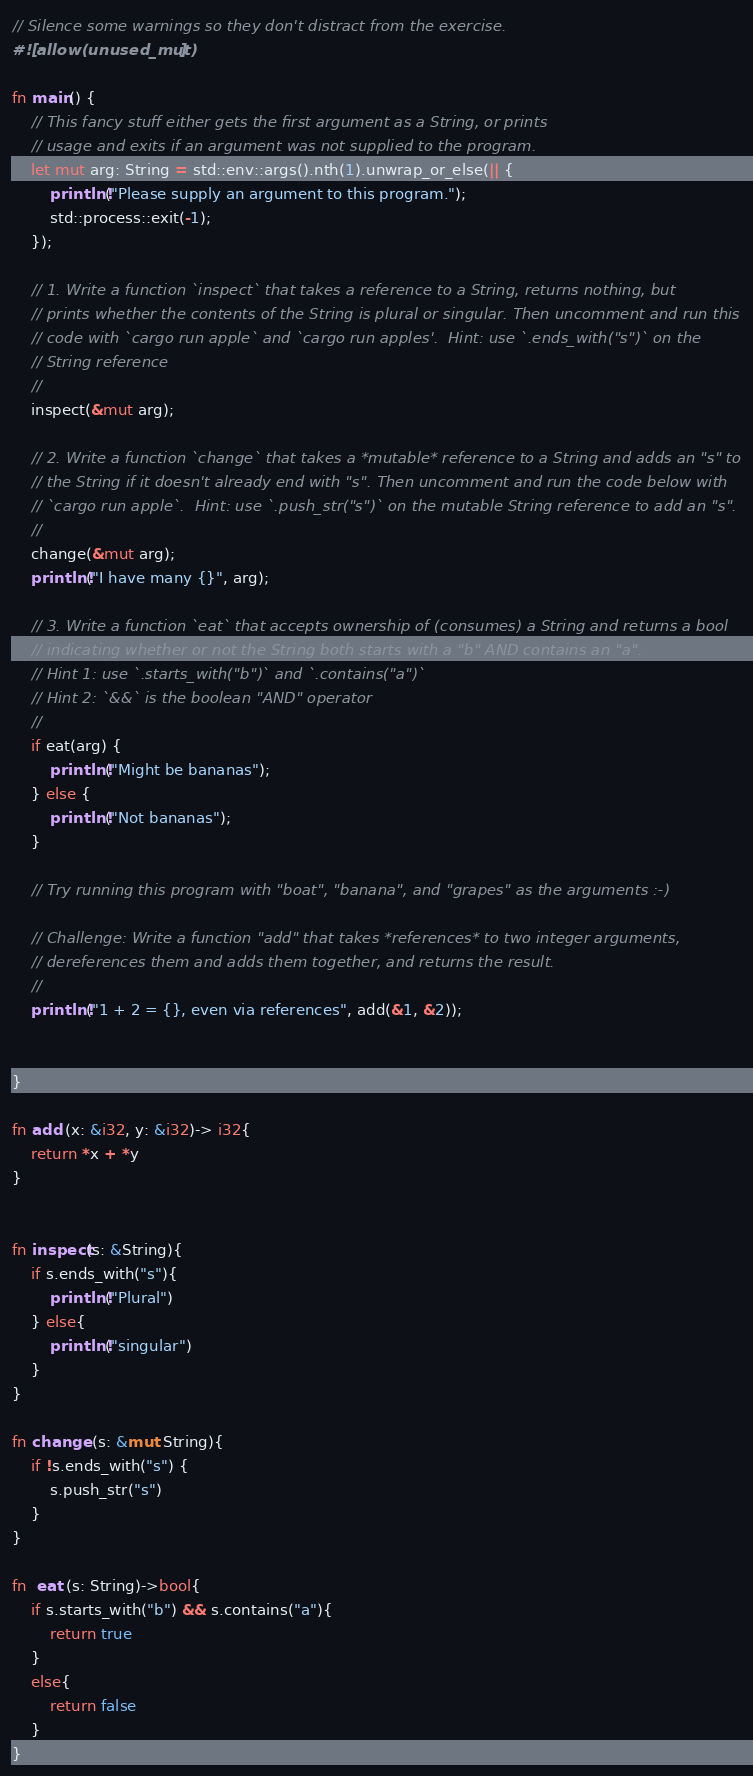<code> <loc_0><loc_0><loc_500><loc_500><_Rust_>// Silence some warnings so they don't distract from the exercise.
#![allow(unused_mut)]

fn main() {
    // This fancy stuff either gets the first argument as a String, or prints
    // usage and exits if an argument was not supplied to the program.
    let mut arg: String = std::env::args().nth(1).unwrap_or_else(|| {
        println!("Please supply an argument to this program.");
        std::process::exit(-1);
    });

    // 1. Write a function `inspect` that takes a reference to a String, returns nothing, but
    // prints whether the contents of the String is plural or singular. Then uncomment and run this
    // code with `cargo run apple` and `cargo run apples'.  Hint: use `.ends_with("s")` on the
    // String reference
    //
    inspect(&mut arg);

    // 2. Write a function `change` that takes a *mutable* reference to a String and adds an "s" to
    // the String if it doesn't already end with "s". Then uncomment and run the code below with
    // `cargo run apple`.  Hint: use `.push_str("s")` on the mutable String reference to add an "s".
    //
    change(&mut arg);
    println!("I have many {}", arg);

    // 3. Write a function `eat` that accepts ownership of (consumes) a String and returns a bool
    // indicating whether or not the String both starts with a "b" AND contains an "a".
    // Hint 1: use `.starts_with("b")` and `.contains("a")`
    // Hint 2: `&&` is the boolean "AND" operator
    //
    if eat(arg) {
        println!("Might be bananas");
    } else {
        println!("Not bananas");
    }

    // Try running this program with "boat", "banana", and "grapes" as the arguments :-)

    // Challenge: Write a function "add" that takes *references* to two integer arguments,
    // dereferences them and adds them together, and returns the result.
    //
    println!("1 + 2 = {}, even via references", add(&1, &2));
    
    
}

fn add (x: &i32, y: &i32)-> i32{
    return *x + *y
}


fn inspect(s: &String){
    if s.ends_with("s"){
        println!("Plural")
    } else{
        println!("singular")
    }
}

fn change (s: &mut String){
    if !s.ends_with("s") {
        s.push_str("s")
    }
}

fn  eat (s: String)->bool{
    if s.starts_with("b") && s.contains("a"){
        return true
    }
    else{
        return false
    } 
}</code> 